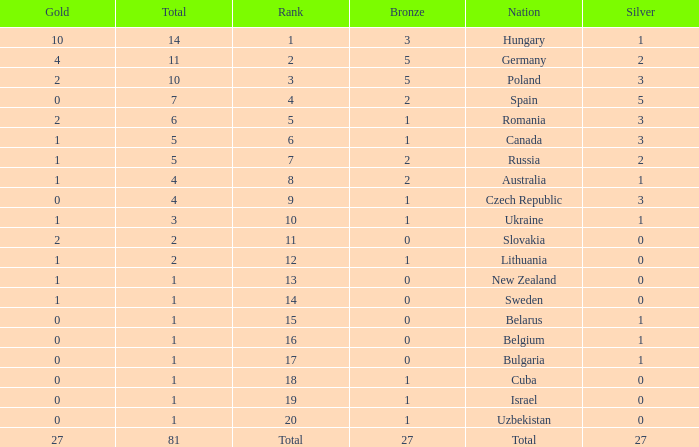Which Rank has a Bronze of 1, and a Nation of lithuania? 12.0. 